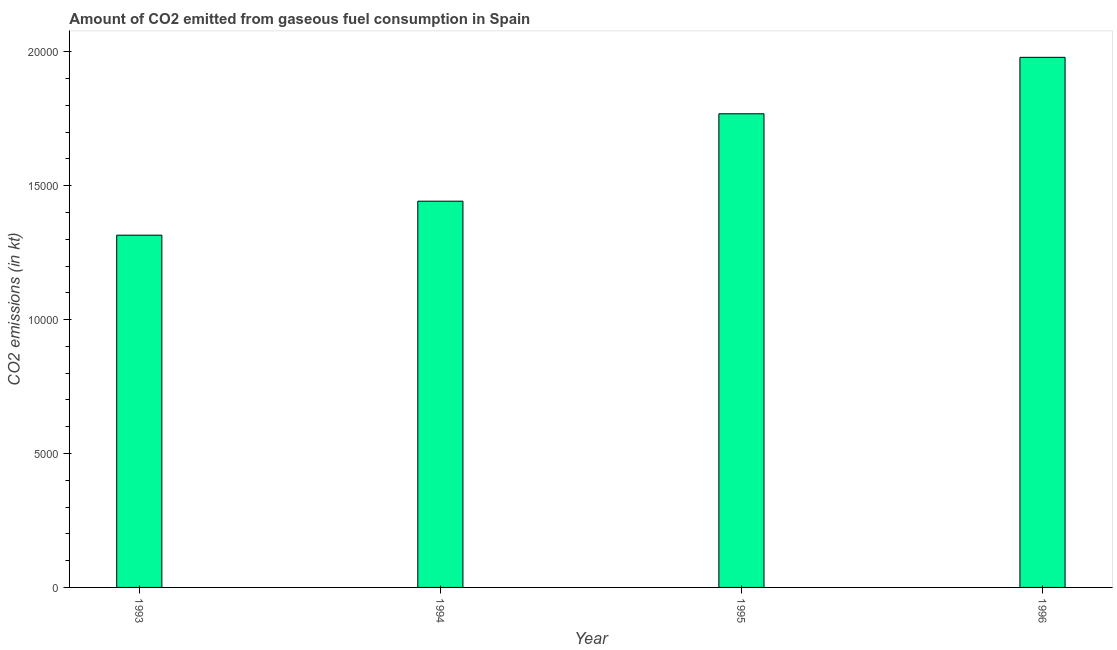Does the graph contain grids?
Make the answer very short. No. What is the title of the graph?
Offer a very short reply. Amount of CO2 emitted from gaseous fuel consumption in Spain. What is the label or title of the Y-axis?
Your answer should be compact. CO2 emissions (in kt). What is the co2 emissions from gaseous fuel consumption in 1994?
Your response must be concise. 1.44e+04. Across all years, what is the maximum co2 emissions from gaseous fuel consumption?
Ensure brevity in your answer.  1.98e+04. Across all years, what is the minimum co2 emissions from gaseous fuel consumption?
Offer a very short reply. 1.32e+04. What is the sum of the co2 emissions from gaseous fuel consumption?
Give a very brief answer. 6.51e+04. What is the difference between the co2 emissions from gaseous fuel consumption in 1995 and 1996?
Keep it short and to the point. -2108.53. What is the average co2 emissions from gaseous fuel consumption per year?
Provide a succinct answer. 1.63e+04. What is the median co2 emissions from gaseous fuel consumption?
Offer a very short reply. 1.61e+04. What is the ratio of the co2 emissions from gaseous fuel consumption in 1994 to that in 1996?
Ensure brevity in your answer.  0.73. Is the difference between the co2 emissions from gaseous fuel consumption in 1993 and 1996 greater than the difference between any two years?
Offer a terse response. Yes. What is the difference between the highest and the second highest co2 emissions from gaseous fuel consumption?
Offer a terse response. 2108.53. Is the sum of the co2 emissions from gaseous fuel consumption in 1993 and 1994 greater than the maximum co2 emissions from gaseous fuel consumption across all years?
Keep it short and to the point. Yes. What is the difference between the highest and the lowest co2 emissions from gaseous fuel consumption?
Keep it short and to the point. 6640.94. How many years are there in the graph?
Your response must be concise. 4. What is the difference between two consecutive major ticks on the Y-axis?
Offer a very short reply. 5000. Are the values on the major ticks of Y-axis written in scientific E-notation?
Ensure brevity in your answer.  No. What is the CO2 emissions (in kt) in 1993?
Keep it short and to the point. 1.32e+04. What is the CO2 emissions (in kt) of 1994?
Provide a succinct answer. 1.44e+04. What is the CO2 emissions (in kt) in 1995?
Provide a short and direct response. 1.77e+04. What is the CO2 emissions (in kt) of 1996?
Your answer should be compact. 1.98e+04. What is the difference between the CO2 emissions (in kt) in 1993 and 1994?
Ensure brevity in your answer.  -1268.78. What is the difference between the CO2 emissions (in kt) in 1993 and 1995?
Give a very brief answer. -4532.41. What is the difference between the CO2 emissions (in kt) in 1993 and 1996?
Provide a succinct answer. -6640.94. What is the difference between the CO2 emissions (in kt) in 1994 and 1995?
Keep it short and to the point. -3263.63. What is the difference between the CO2 emissions (in kt) in 1994 and 1996?
Your response must be concise. -5372.15. What is the difference between the CO2 emissions (in kt) in 1995 and 1996?
Ensure brevity in your answer.  -2108.53. What is the ratio of the CO2 emissions (in kt) in 1993 to that in 1994?
Provide a short and direct response. 0.91. What is the ratio of the CO2 emissions (in kt) in 1993 to that in 1995?
Your response must be concise. 0.74. What is the ratio of the CO2 emissions (in kt) in 1993 to that in 1996?
Offer a very short reply. 0.67. What is the ratio of the CO2 emissions (in kt) in 1994 to that in 1995?
Offer a very short reply. 0.81. What is the ratio of the CO2 emissions (in kt) in 1994 to that in 1996?
Your answer should be compact. 0.73. What is the ratio of the CO2 emissions (in kt) in 1995 to that in 1996?
Provide a short and direct response. 0.89. 